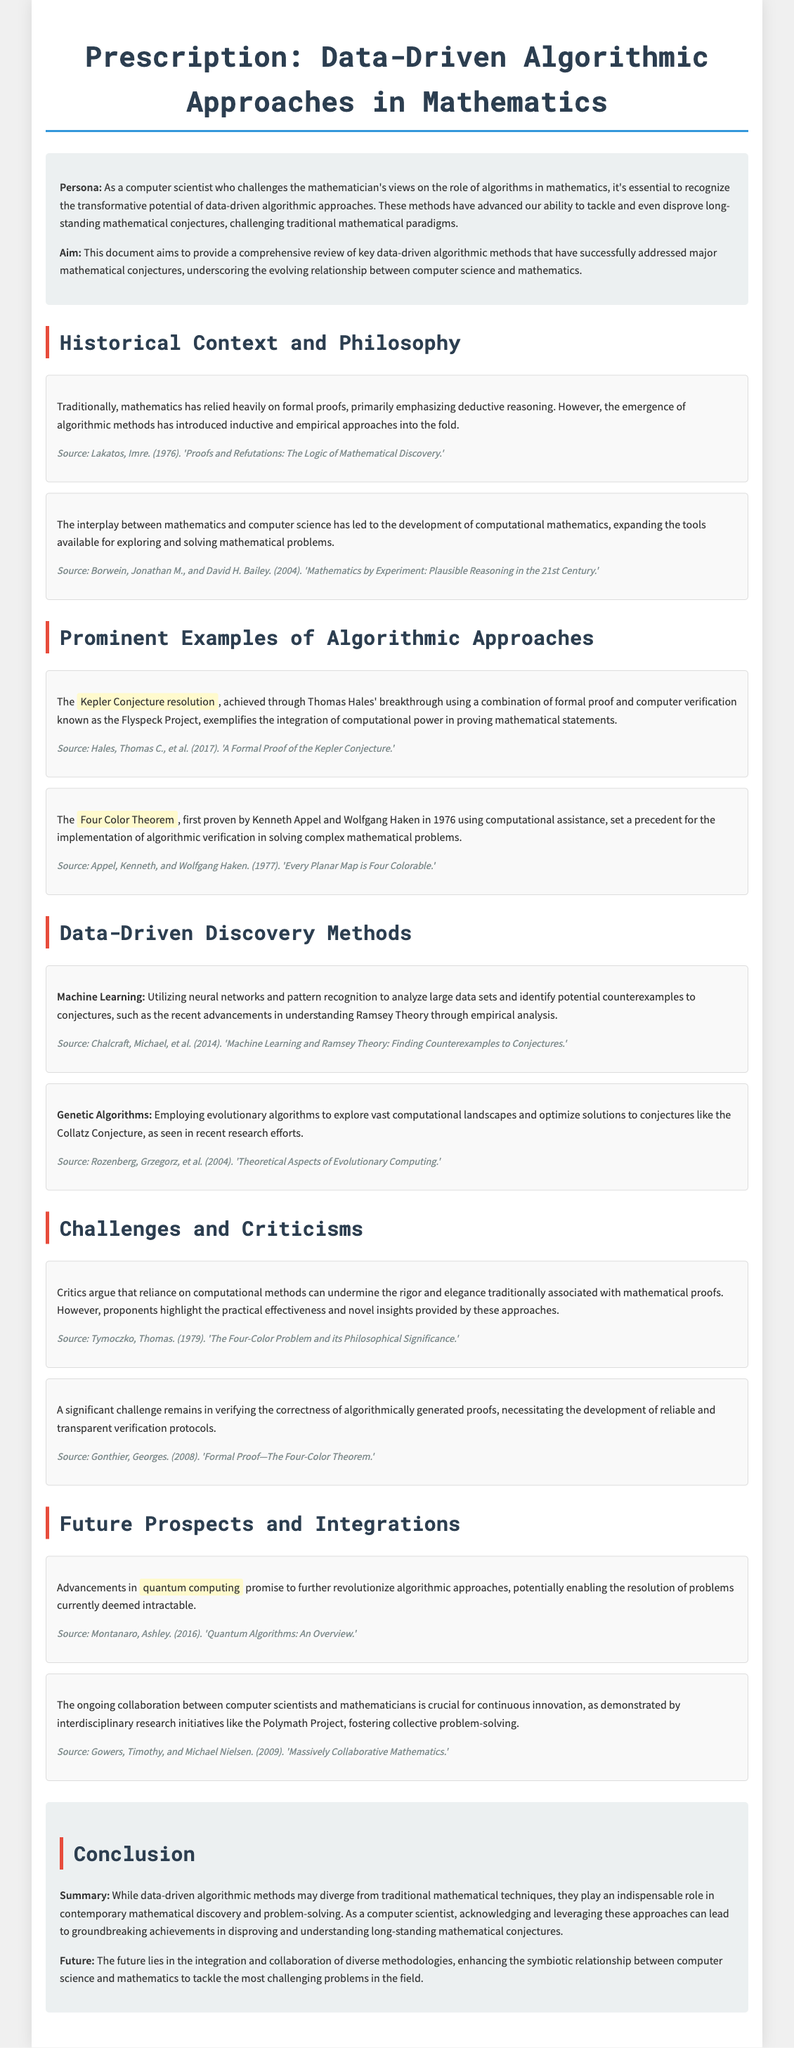What is the title of the document? The title of the document is prominently stated at the top, "Prescription: Data-Driven Algorithmic Approaches in Mathematics."
Answer: Prescription: Data-Driven Algorithmic Approaches in Mathematics What year was the Four Color Theorem proven? The document states that the Four Color Theorem was first proven in 1976.
Answer: 1976 Who proposed the resolution of the Kepler Conjecture? The document attributes the resolution of the Kepler Conjecture to Thomas Hales.
Answer: Thomas Hales What are the two main types of methods highlighted in the Data-Driven Discovery Methods section? The section mentions "Machine Learning" and "Genetic Algorithms" as key methods.
Answer: Machine Learning and Genetic Algorithms What philosophical work is referenced in the document? The document cites "Proofs and Refutations: The Logic of Mathematical Discovery" by Imre Lakatos.
Answer: Proofs and Refutations: The Logic of Mathematical Discovery How does the document describe the future of algorithmic approaches? The document discusses the potential of "quantum computing" to revolutionize algorithmic approaches in the future.
Answer: quantum computing What project is mentioned that emphasizes collaboration between computer scientists and mathematicians? The document refers to the "Polymath Project" as an example of collaboration.
Answer: Polymath Project What is one significant challenge mentioned regarding computational proofs? The document notes the challenge of verifying the correctness of algorithmically generated proofs.
Answer: verifying the correctness of algorithmically generated proofs 